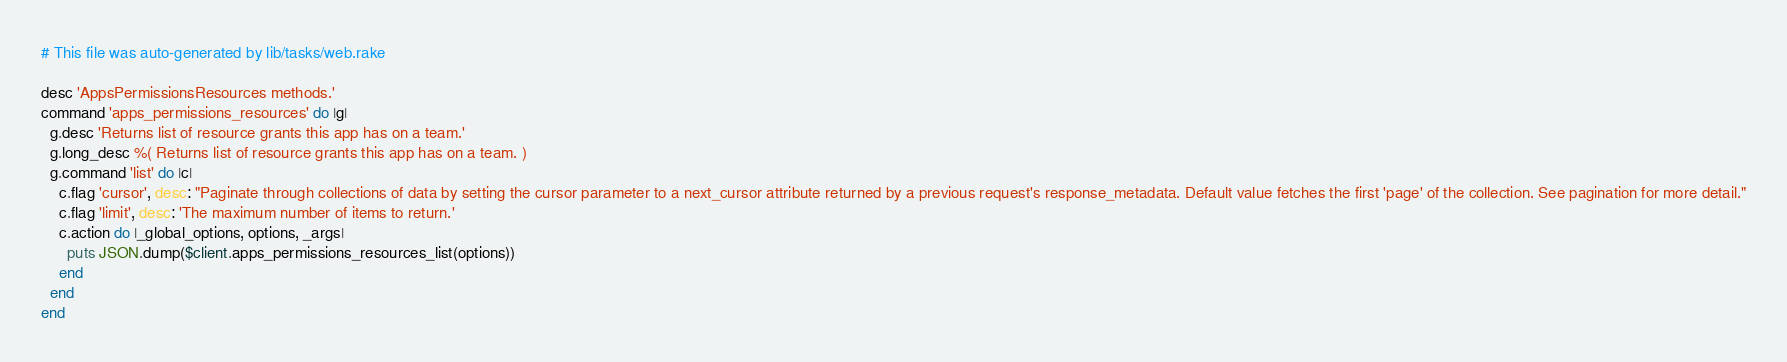<code> <loc_0><loc_0><loc_500><loc_500><_Ruby_># This file was auto-generated by lib/tasks/web.rake

desc 'AppsPermissionsResources methods.'
command 'apps_permissions_resources' do |g|
  g.desc 'Returns list of resource grants this app has on a team.'
  g.long_desc %( Returns list of resource grants this app has on a team. )
  g.command 'list' do |c|
    c.flag 'cursor', desc: "Paginate through collections of data by setting the cursor parameter to a next_cursor attribute returned by a previous request's response_metadata. Default value fetches the first 'page' of the collection. See pagination for more detail."
    c.flag 'limit', desc: 'The maximum number of items to return.'
    c.action do |_global_options, options, _args|
      puts JSON.dump($client.apps_permissions_resources_list(options))
    end
  end
end
</code> 